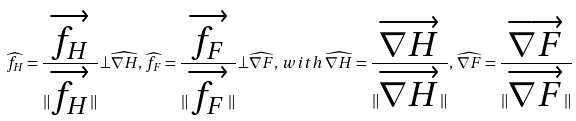<formula> <loc_0><loc_0><loc_500><loc_500>\widehat { f _ { H } } = \frac { \overrightarrow { f _ { H } } } { \| \overrightarrow { f _ { H } } \| } \bot \widehat { \nabla H } , \, \widehat { f _ { F } } = \frac { \overrightarrow { f _ { F } } } { \| \overrightarrow { f _ { F } } \| } \bot \widehat { \nabla F } , \, w i t h \, \widehat { \nabla H } = \frac { \overrightarrow { \nabla H } } { \| \overrightarrow { \nabla H } \| } , \, \widehat { \nabla F } = \frac { \overrightarrow { \nabla F } } { \| \overrightarrow { \nabla F } \| }</formula> 